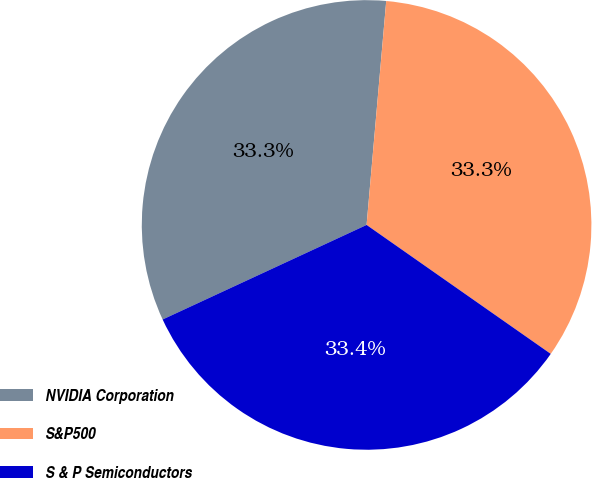Convert chart. <chart><loc_0><loc_0><loc_500><loc_500><pie_chart><fcel>NVIDIA Corporation<fcel>S&P500<fcel>S & P Semiconductors<nl><fcel>33.3%<fcel>33.33%<fcel>33.37%<nl></chart> 